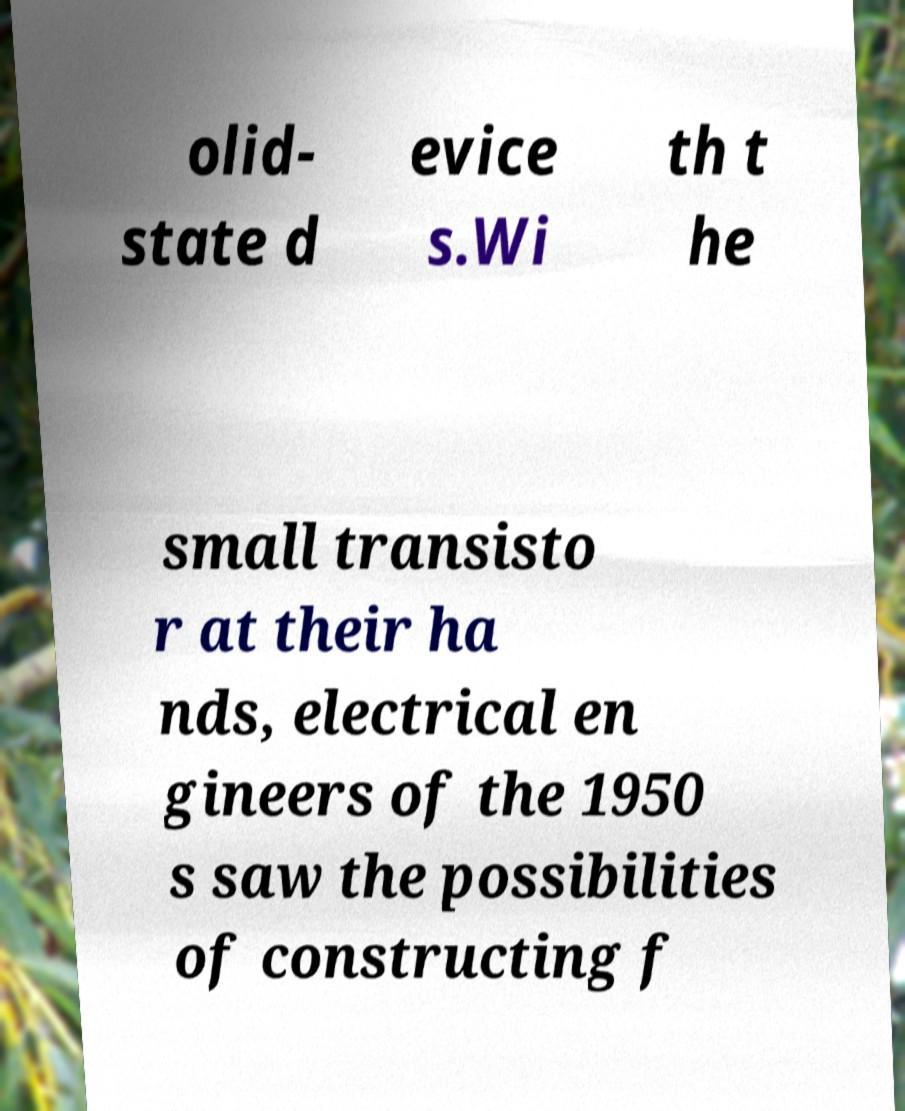Please read and relay the text visible in this image. What does it say? olid- state d evice s.Wi th t he small transisto r at their ha nds, electrical en gineers of the 1950 s saw the possibilities of constructing f 